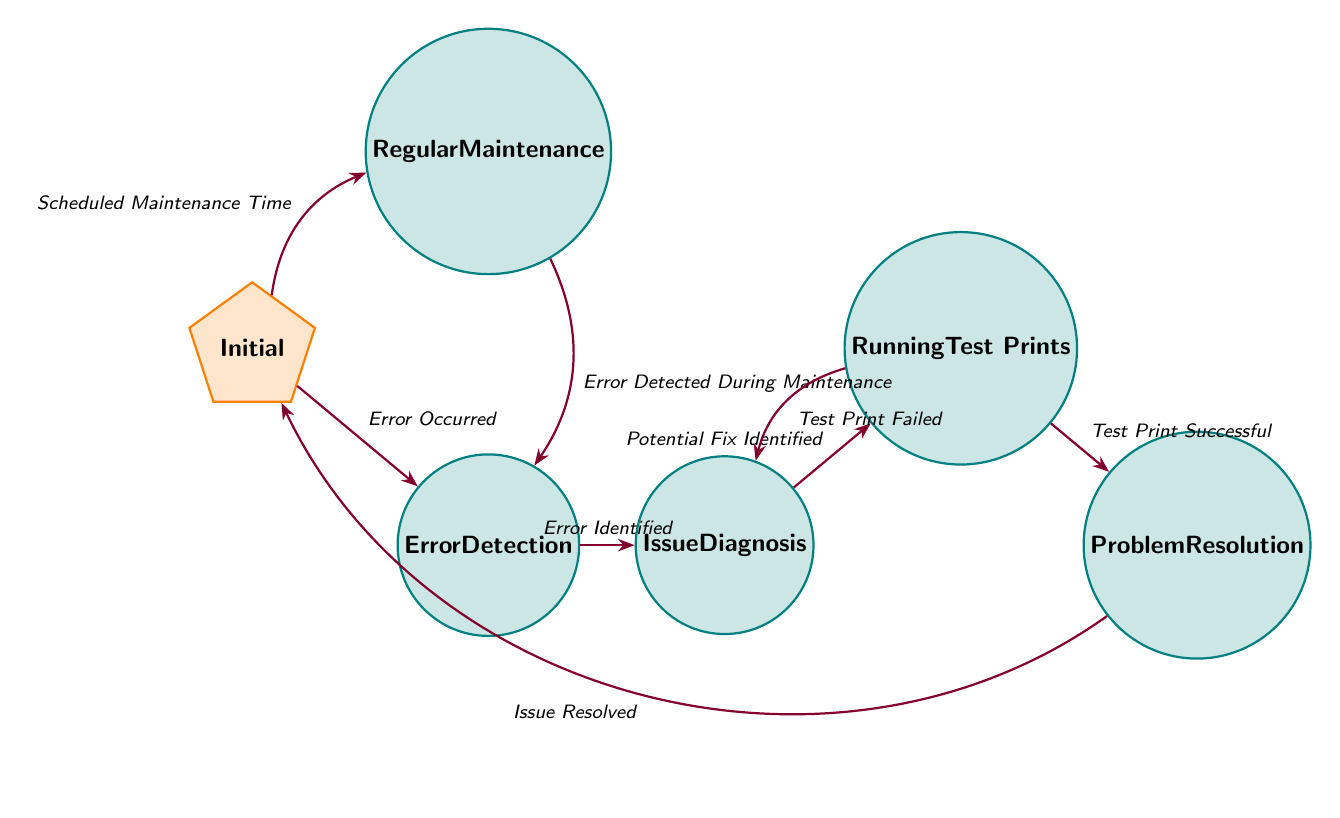What is the initial state of the FSM? The diagram designates the "Initial" node as the starting point, identifiable by the orange polygon shape representing the initial state.
Answer: Initial How many states are there in total? By counting the states depicted in the diagram, we see "Initial," "Regular Maintenance," "Error Detection," "Issue Diagnosis," "Running Test Prints," and "Problem Resolution." This totals to six distinct states.
Answer: 6 What transition occurs from "Initial" to "Regular Maintenance"? The diagram indicates that the transition from "Initial" to "Regular Maintenance" takes place when the condition labeled "Scheduled Maintenance Time" is met. A visual arrow connects these two states.
Answer: Scheduled Maintenance Time Which state follows "Running Test Prints" if the test print is successful? According to the diagram, if the "Test Print Successful" transition occurs from "Running Test Prints," it leads directly to the "Problem Resolution" state. This is illustrated by the directed edge connecting these two states with the condition specified.
Answer: Problem Resolution What happens if the test print fails in the "Running Test Prints" state? If the condition "Test Print Failed" is encountered in the "Running Test Prints" state, the diagram shows a return to the "Issue Diagnosis" state, indicated by an arrow in that direction.
Answer: Issue Diagnosis Which state is reached after successfully resolving a problem? Upon successfully resolving a problem, represented by the transition labeled "Issue Resolved," the FSM directs to return to the "Initial" state. This is indicated by the bending transition arrow coming from "Problem Resolution."
Answer: Initial What are two of the tasks under "Regular Maintenance"? The diagram specifies four tasks under "Regular Maintenance," including "Cleaning Nozzle" and "Updating Firmware." These tasks are visible as sub-items within the "Regular Maintenance" state description.
Answer: Cleaning Nozzle, Updating Firmware What must happen for the "Issue Diagnosis" state to be reached from "Error Detection"? The "Error Detection" state transitions to "Issue Diagnosis" when the condition "Error Identified" is satisfied, as shown by the connecting arrow between those two states in the diagram.
Answer: Error Identified How many transitions lead directly from "Running Test Prints"? The diagram displays two possible transitions leading from "Running Test Prints": one to "Problem Resolution" (if the test print is successful) and one back to "Issue Diagnosis" (if the test print fails), amounting to two transitions originating from this state.
Answer: 2 